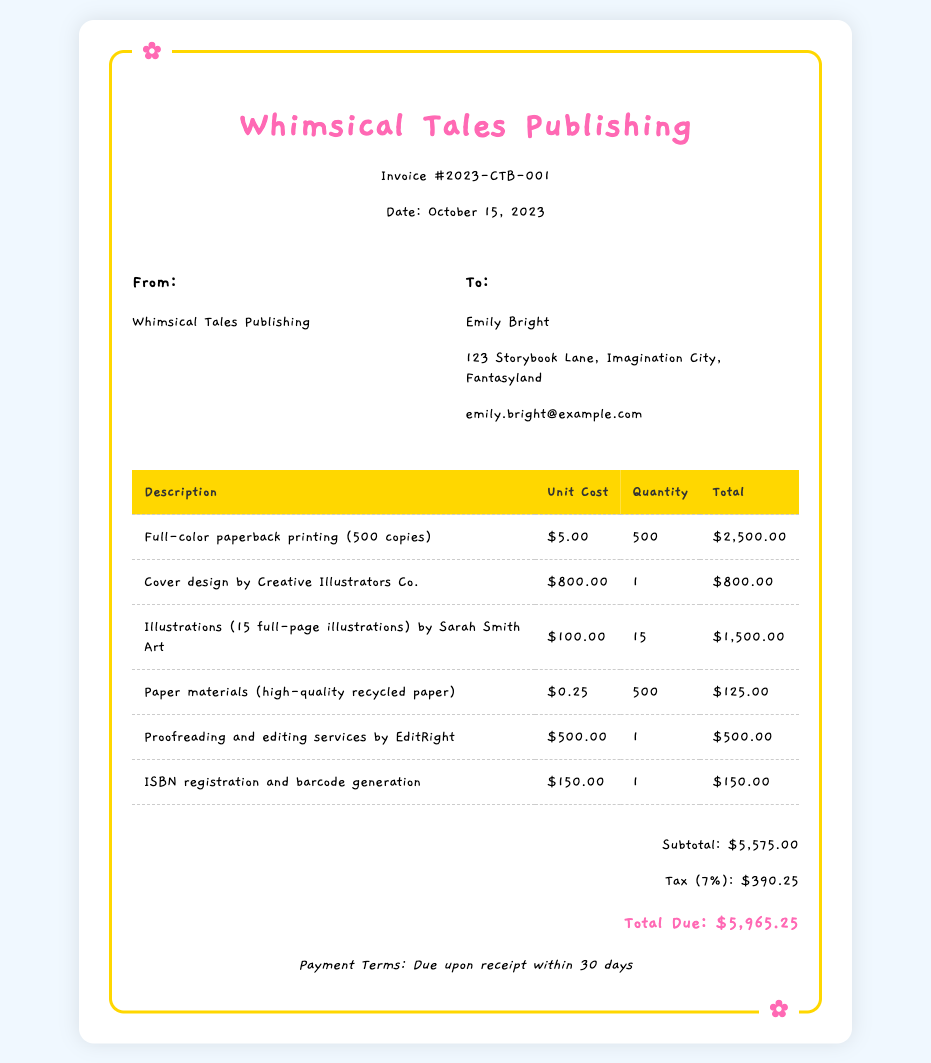What is the invoice number? The invoice number is located near the top of the document.
Answer: 2023-CTB-001 Who is the client listed on the invoice? The client's name is mentioned in the "To" section of the invoice.
Answer: Emily Bright What is the total amount due? The total amount due is summarized at the end of the invoice.
Answer: $5,965.25 How many copies of the paperback are being printed? The quantity of printed copies is provided in the description of the printing cost.
Answer: 500 What is the cost of the illustrations? The cost for the illustrations is specified next to the illustration description in the table.
Answer: $1,500.00 What service does EditRight provide? EditRight's service is mentioned in the billing table.
Answer: Proofreading and editing services What is the subtotal of the invoice? The subtotal can be found before the tax in the totals section.
Answer: $5,575.00 What is the tax rate applied to the invoice? The tax rate is indicated in the tax line in the totals section.
Answer: 7% What is the payment term stated in the invoice? The payment terms are provided towards the end of the document.
Answer: Due upon receipt within 30 days 